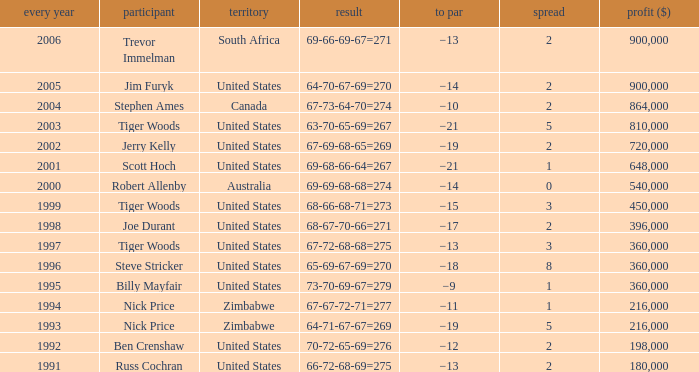What is canada's margin? 2.0. 